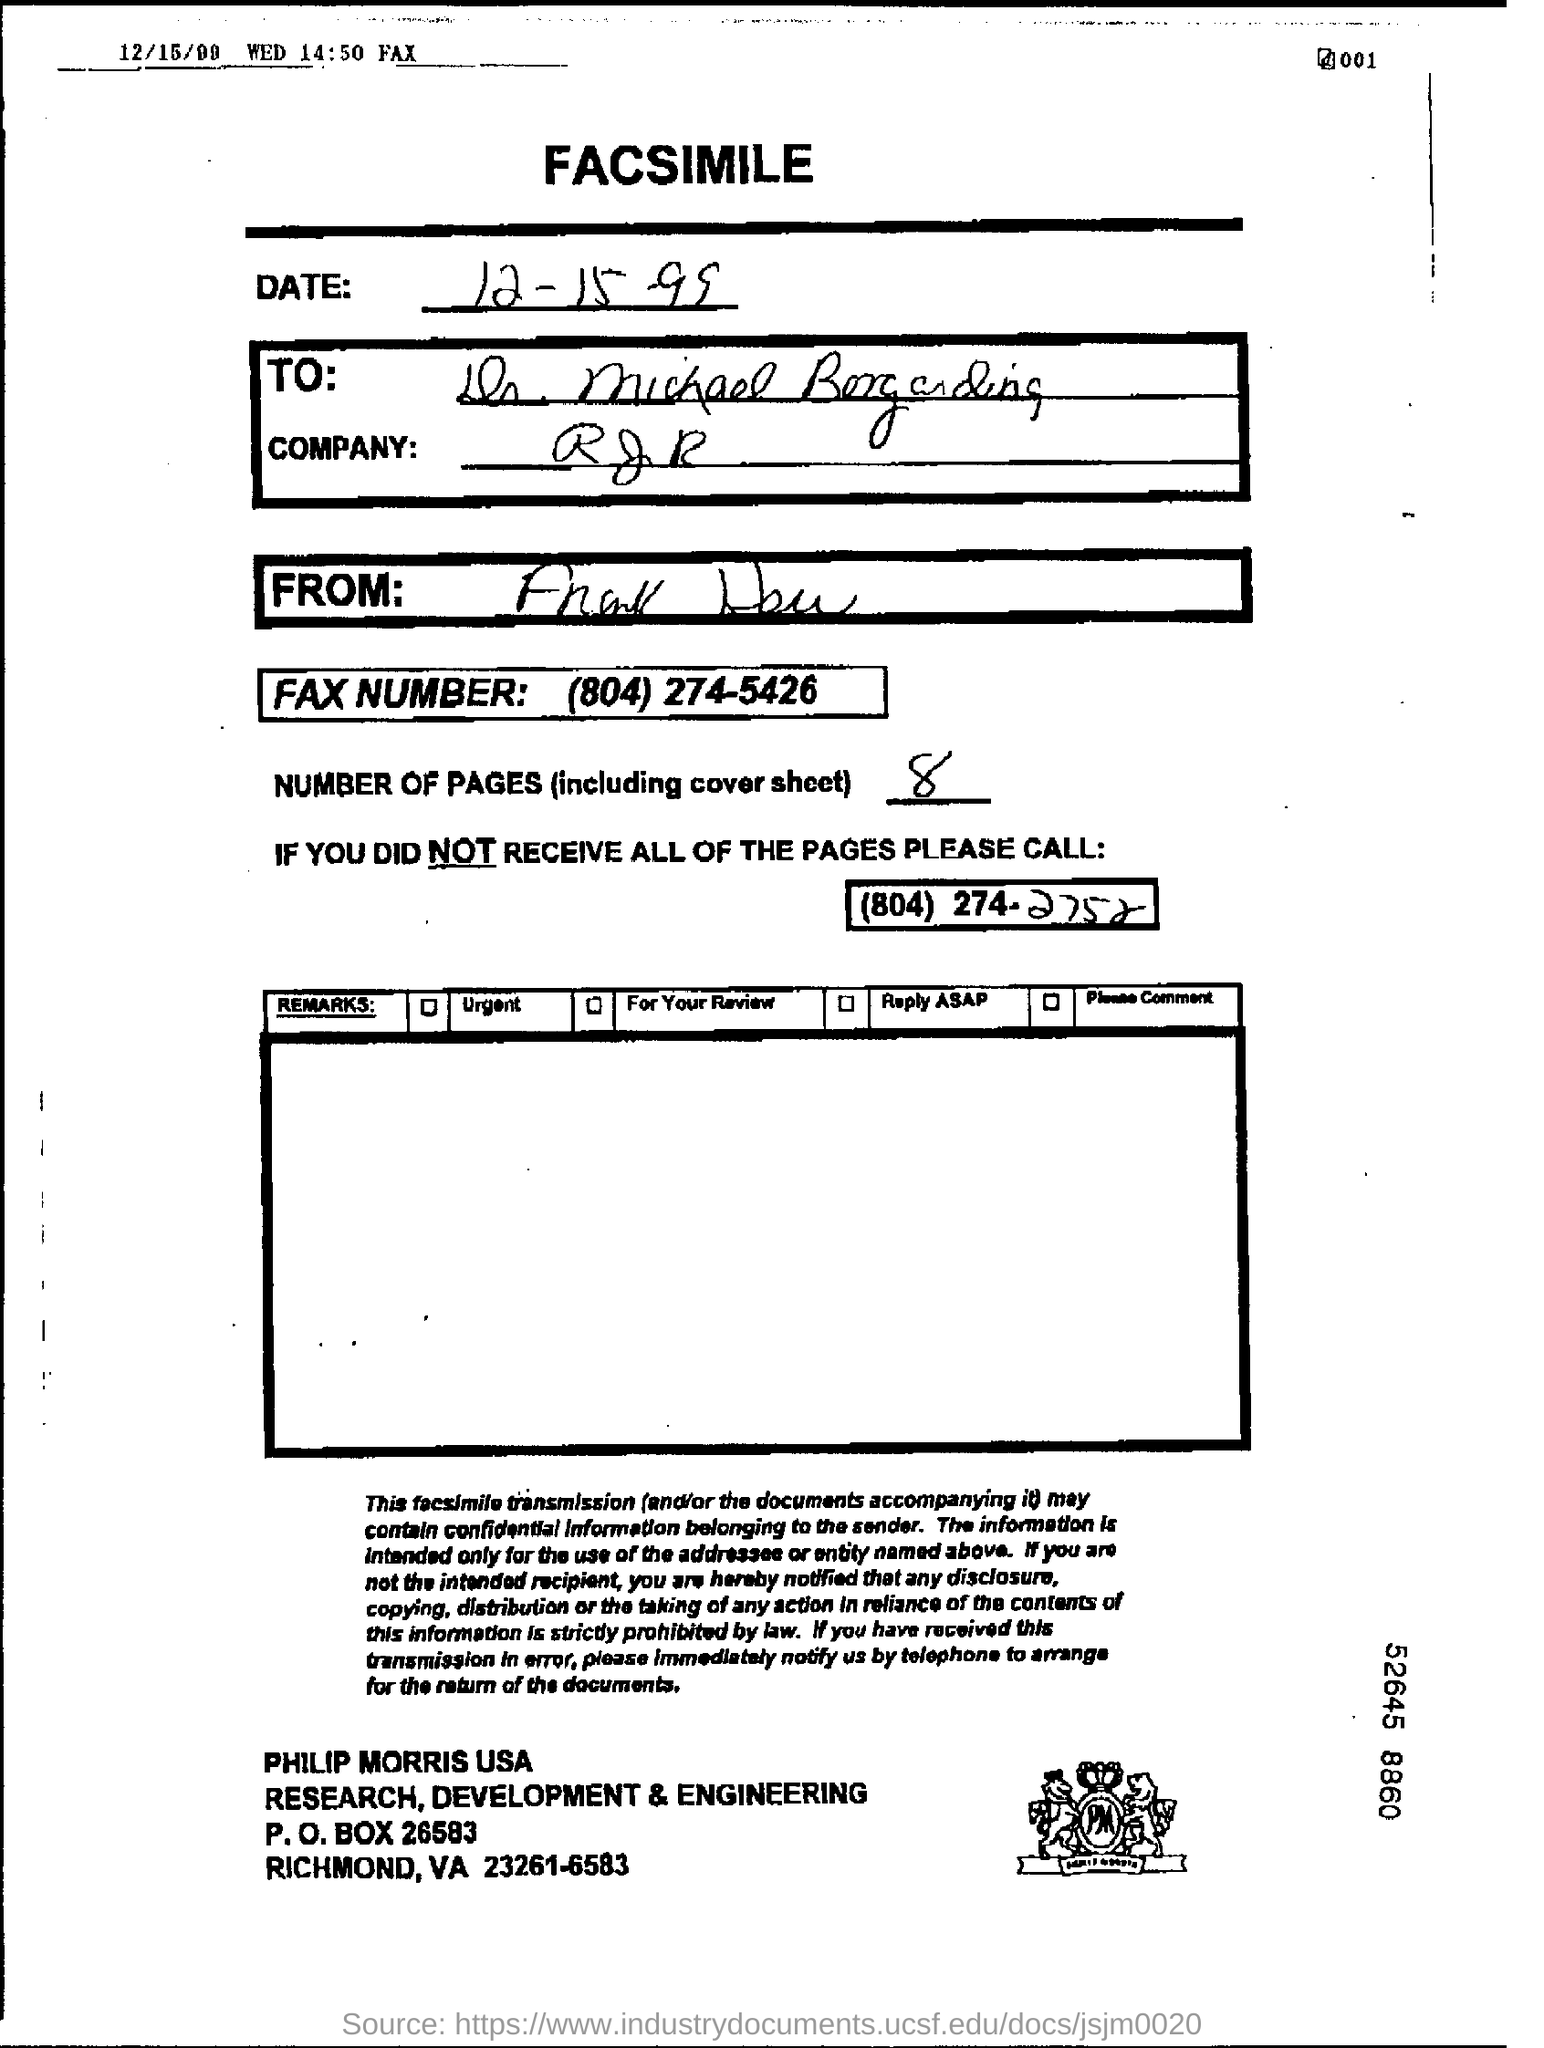What is the date of the document?
Your answer should be very brief. 12-15-99. What is the fax number mentioned in the facsimile?
Your answer should be very brief. (804) 274-5426. What is the fax number?
Make the answer very short. (804)274-5426. What is the number of pages including cover?
Provide a short and direct response. 8. What is the no of pages in the fax including cover sheet?
Offer a very short reply. 8. 